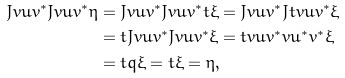Convert formula to latex. <formula><loc_0><loc_0><loc_500><loc_500>J v u v ^ { * } J v u v ^ { * } \eta & = J v u v ^ { * } J v u v ^ { * } t \xi = J v u v ^ { * } J t v u v ^ { * } \xi \\ & = t J v u v ^ { * } J v u v ^ { * } \xi = t v u v ^ { * } v u ^ { * } v ^ { * } \xi \\ & = t q \xi = t \xi = \eta ,</formula> 